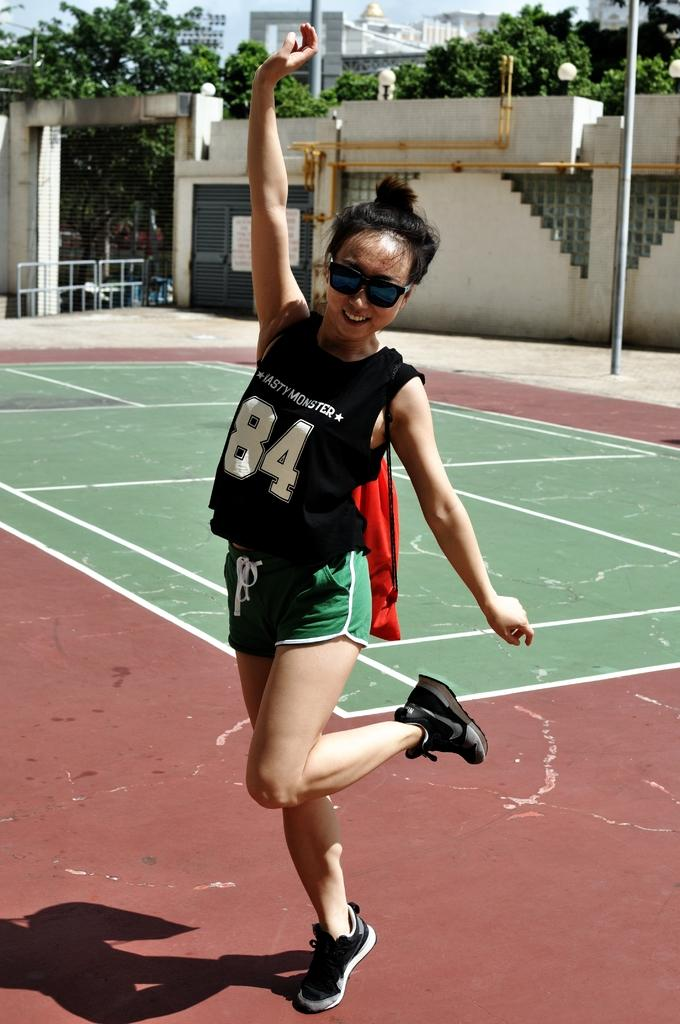<image>
Summarize the visual content of the image. A woman wearing jersey number 84 stands on a basketball court 